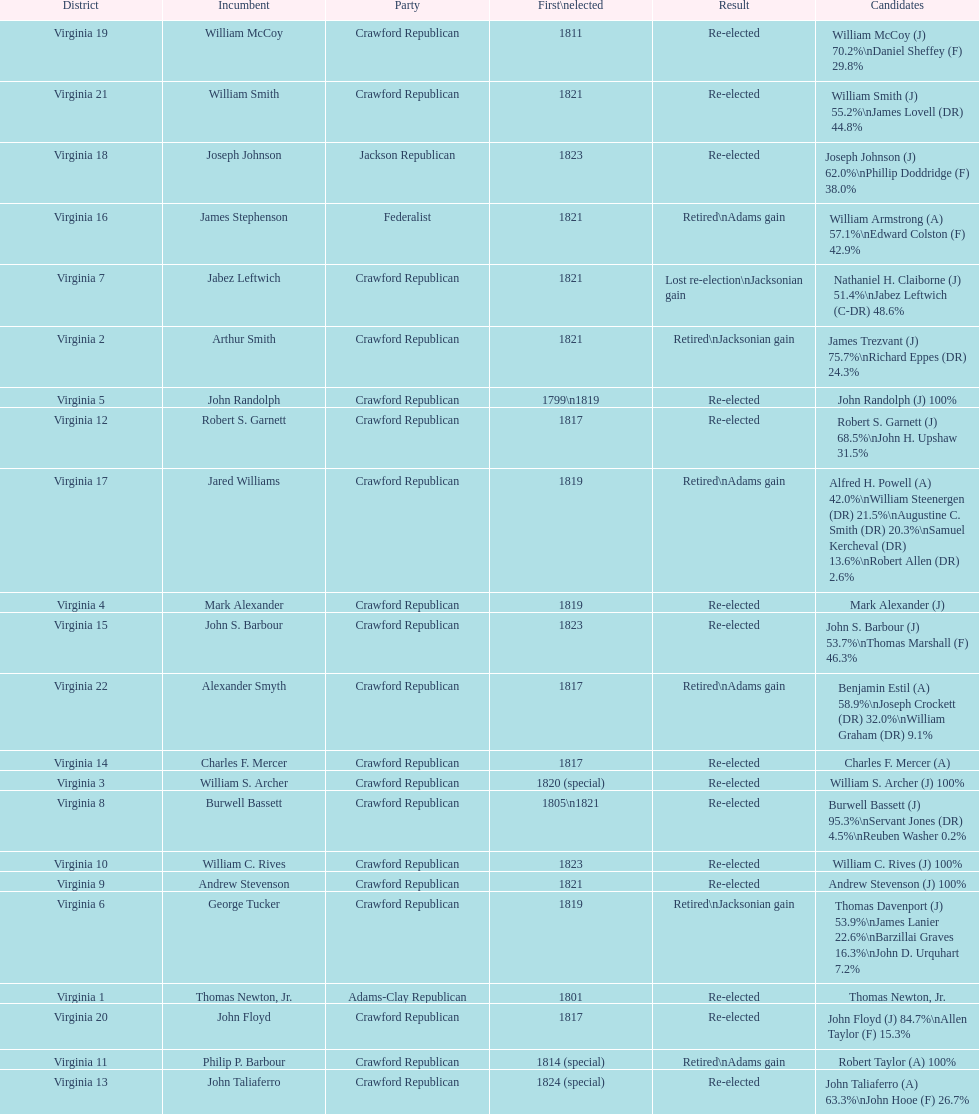Tell me the number of people first elected in 1817. 4. 